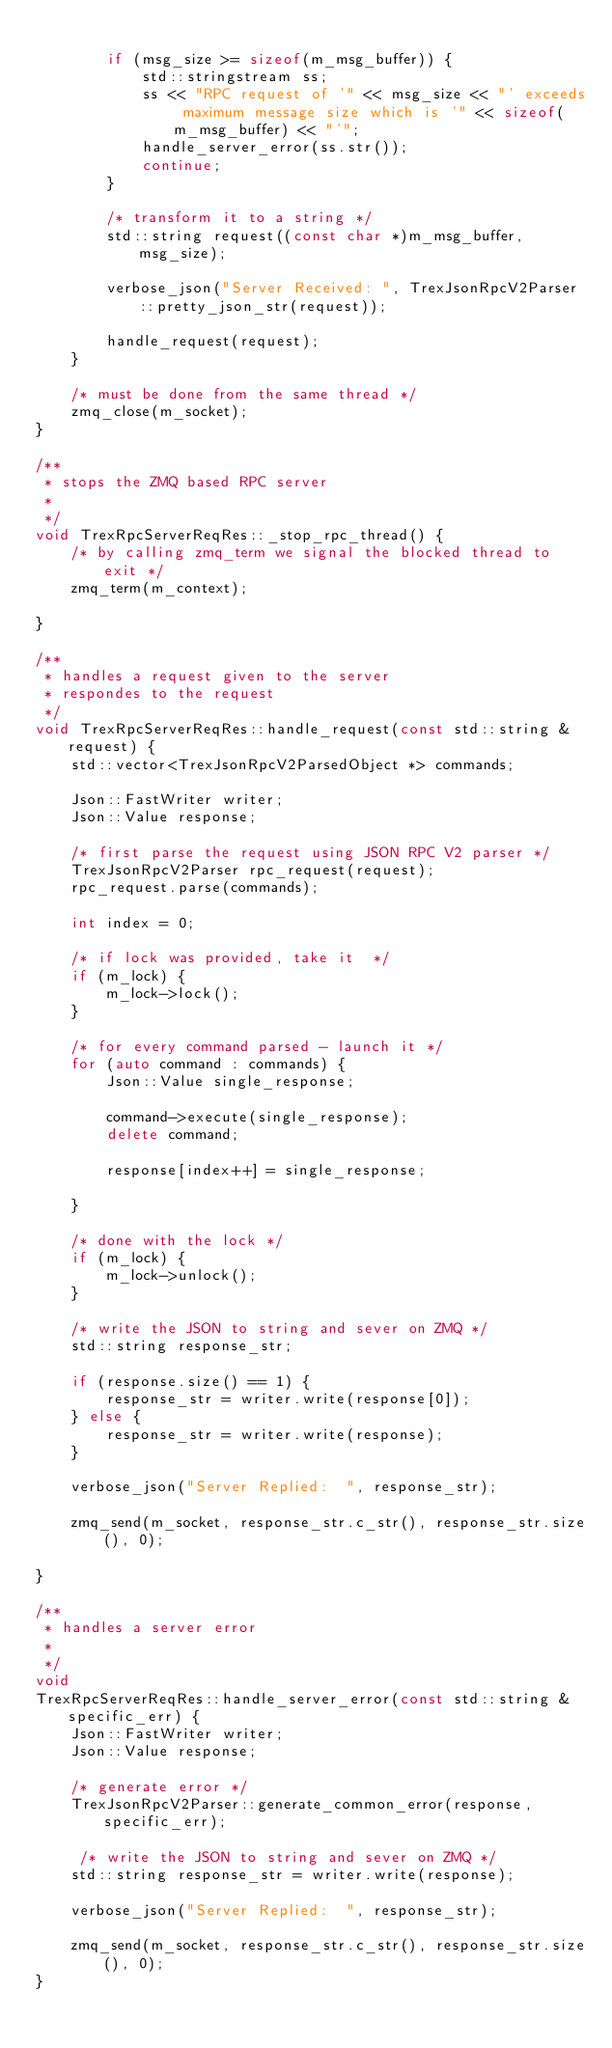Convert code to text. <code><loc_0><loc_0><loc_500><loc_500><_C++_>
        if (msg_size >= sizeof(m_msg_buffer)) {
            std::stringstream ss;
            ss << "RPC request of '" << msg_size << "' exceeds maximum message size which is '" << sizeof(m_msg_buffer) << "'";
            handle_server_error(ss.str());
            continue;
        }

        /* transform it to a string */
        std::string request((const char *)m_msg_buffer, msg_size);

        verbose_json("Server Received: ", TrexJsonRpcV2Parser::pretty_json_str(request));

        handle_request(request);
    }

    /* must be done from the same thread */
    zmq_close(m_socket);
}

/**
 * stops the ZMQ based RPC server
 * 
 */
void TrexRpcServerReqRes::_stop_rpc_thread() {
    /* by calling zmq_term we signal the blocked thread to exit */
    zmq_term(m_context);

}

/**
 * handles a request given to the server
 * respondes to the request
 */
void TrexRpcServerReqRes::handle_request(const std::string &request) {
    std::vector<TrexJsonRpcV2ParsedObject *> commands;

    Json::FastWriter writer;
    Json::Value response;

    /* first parse the request using JSON RPC V2 parser */
    TrexJsonRpcV2Parser rpc_request(request);
    rpc_request.parse(commands);

    int index = 0;

    /* if lock was provided, take it  */
    if (m_lock) {
        m_lock->lock();
    }

    /* for every command parsed - launch it */
    for (auto command : commands) {
        Json::Value single_response;

        command->execute(single_response);
        delete command;

        response[index++] = single_response;

    }

    /* done with the lock */
    if (m_lock) {
        m_lock->unlock();
    }

    /* write the JSON to string and sever on ZMQ */
    std::string response_str;

    if (response.size() == 1) {
        response_str = writer.write(response[0]);
    } else {
        response_str = writer.write(response);
    }
    
    verbose_json("Server Replied:  ", response_str);

    zmq_send(m_socket, response_str.c_str(), response_str.size(), 0);
    
}

/**
 * handles a server error
 * 
 */
void 
TrexRpcServerReqRes::handle_server_error(const std::string &specific_err) {
    Json::FastWriter writer;
    Json::Value response;

    /* generate error */
    TrexJsonRpcV2Parser::generate_common_error(response, specific_err);

     /* write the JSON to string and sever on ZMQ */
    std::string response_str = writer.write(response);
    
    verbose_json("Server Replied:  ", response_str);

    zmq_send(m_socket, response_str.c_str(), response_str.size(), 0);
}
</code> 